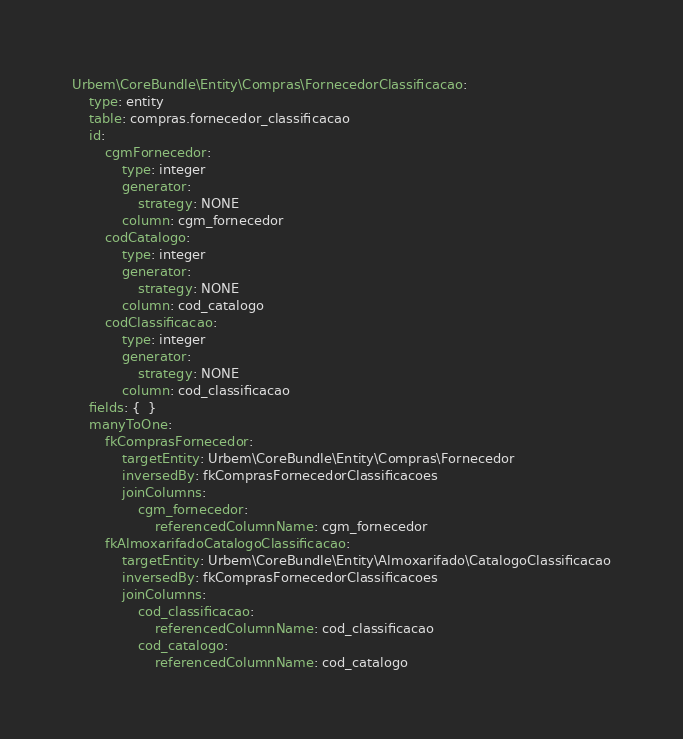<code> <loc_0><loc_0><loc_500><loc_500><_YAML_>Urbem\CoreBundle\Entity\Compras\FornecedorClassificacao:
    type: entity
    table: compras.fornecedor_classificacao
    id:
        cgmFornecedor:
            type: integer
            generator:
                strategy: NONE
            column: cgm_fornecedor
        codCatalogo:
            type: integer
            generator:
                strategy: NONE
            column: cod_catalogo
        codClassificacao:
            type: integer
            generator:
                strategy: NONE
            column: cod_classificacao
    fields: {  }
    manyToOne:
        fkComprasFornecedor:
            targetEntity: Urbem\CoreBundle\Entity\Compras\Fornecedor
            inversedBy: fkComprasFornecedorClassificacoes
            joinColumns:
                cgm_fornecedor:
                    referencedColumnName: cgm_fornecedor
        fkAlmoxarifadoCatalogoClassificacao:
            targetEntity: Urbem\CoreBundle\Entity\Almoxarifado\CatalogoClassificacao
            inversedBy: fkComprasFornecedorClassificacoes
            joinColumns:
                cod_classificacao:
                    referencedColumnName: cod_classificacao
                cod_catalogo:
                    referencedColumnName: cod_catalogo
</code> 